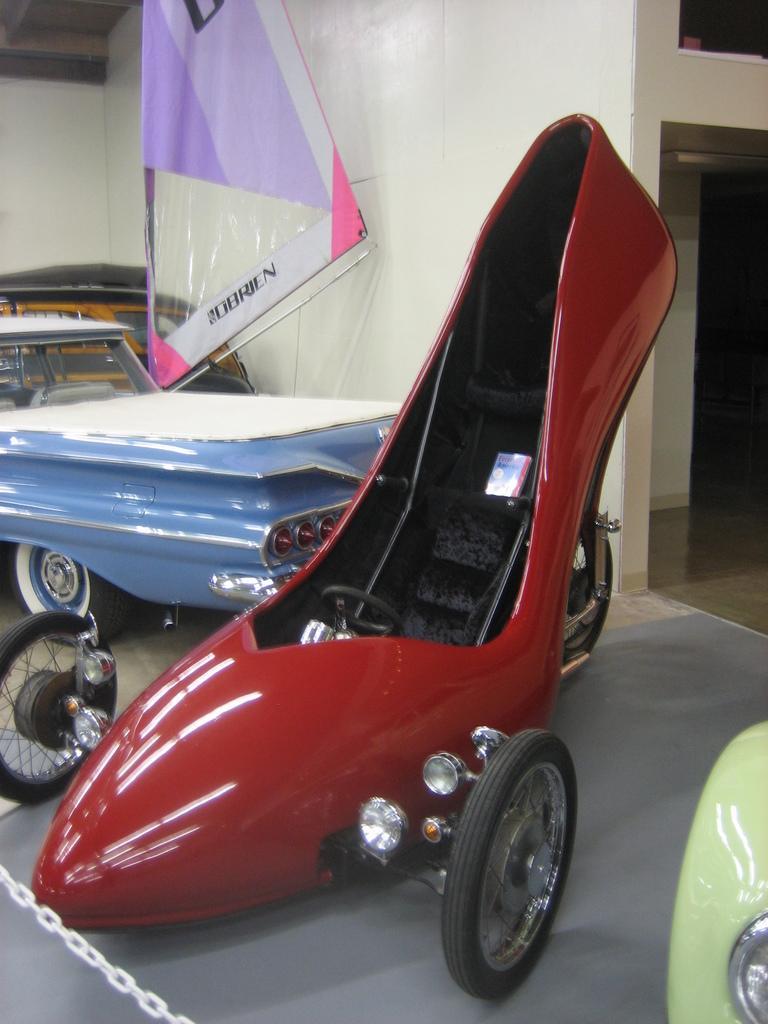Can you describe this image briefly? In the center of the image there are vehicles. In the background of the image there is wall. 